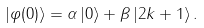<formula> <loc_0><loc_0><loc_500><loc_500>\left | \varphi ( 0 ) \right \rangle = \alpha \left | 0 \right \rangle + \beta \left | 2 k + 1 \right \rangle .</formula> 